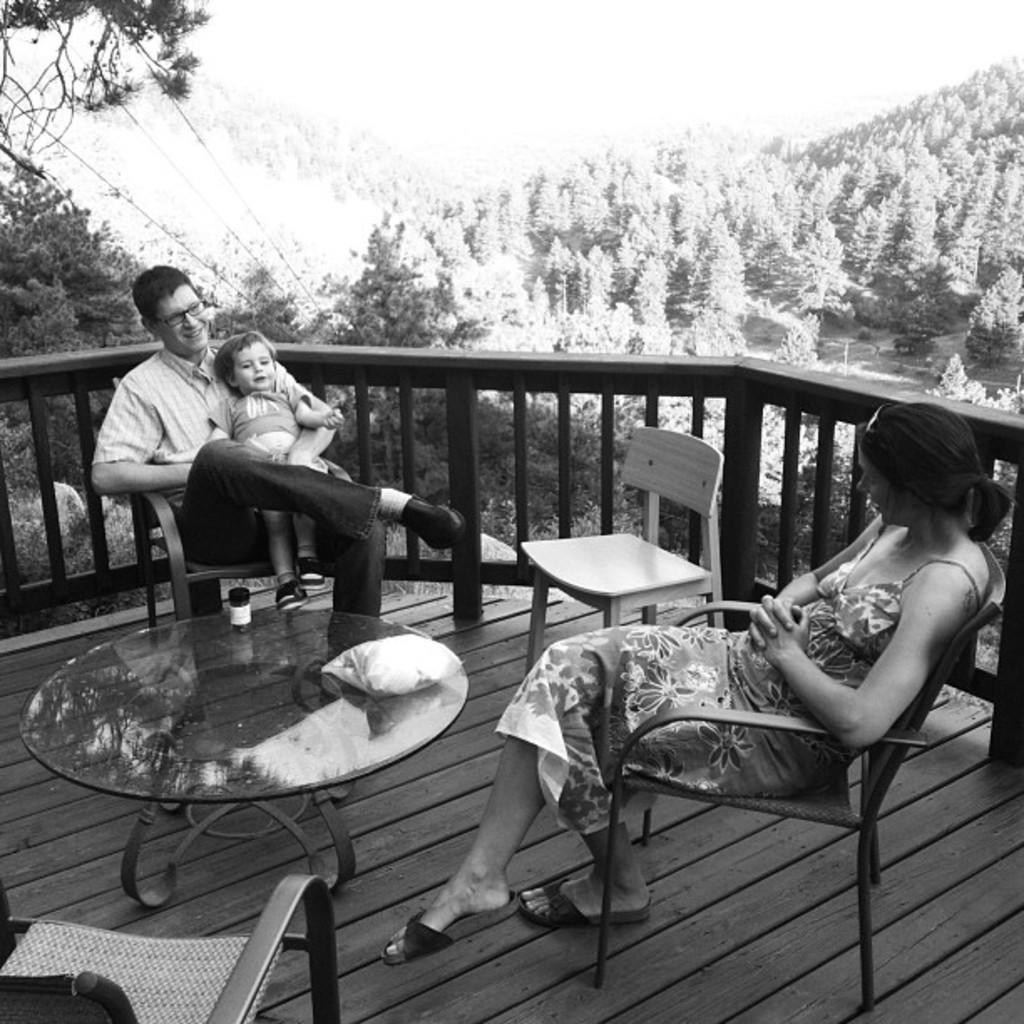In one or two sentences, can you explain what this image depicts? here we can see a man sitting on the chair, and on his lap a baby is sitting, and in front there is the table and some objects on it, and to opposite him a woman is sitting on the chair ,and at side there are trees, and here is the wires. 